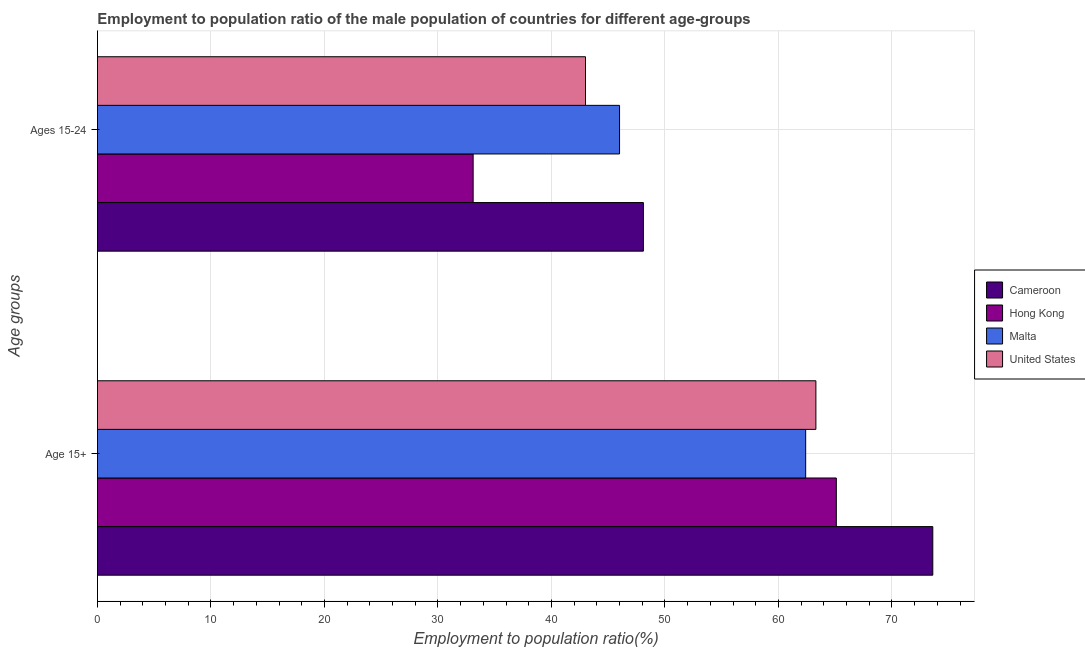How many groups of bars are there?
Make the answer very short. 2. How many bars are there on the 2nd tick from the top?
Your answer should be compact. 4. How many bars are there on the 1st tick from the bottom?
Provide a succinct answer. 4. What is the label of the 2nd group of bars from the top?
Your answer should be very brief. Age 15+. Across all countries, what is the maximum employment to population ratio(age 15-24)?
Your answer should be compact. 48.1. Across all countries, what is the minimum employment to population ratio(age 15-24)?
Offer a very short reply. 33.1. In which country was the employment to population ratio(age 15-24) maximum?
Provide a short and direct response. Cameroon. In which country was the employment to population ratio(age 15-24) minimum?
Provide a short and direct response. Hong Kong. What is the total employment to population ratio(age 15-24) in the graph?
Provide a short and direct response. 170.2. What is the difference between the employment to population ratio(age 15-24) in Hong Kong and that in United States?
Provide a succinct answer. -9.9. What is the difference between the employment to population ratio(age 15+) in Cameroon and the employment to population ratio(age 15-24) in Hong Kong?
Ensure brevity in your answer.  40.5. What is the average employment to population ratio(age 15-24) per country?
Offer a terse response. 42.55. What is the difference between the employment to population ratio(age 15-24) and employment to population ratio(age 15+) in United States?
Ensure brevity in your answer.  -20.3. In how many countries, is the employment to population ratio(age 15-24) greater than 48 %?
Keep it short and to the point. 1. What is the ratio of the employment to population ratio(age 15+) in United States to that in Malta?
Your answer should be compact. 1.01. Is the employment to population ratio(age 15+) in Cameroon less than that in Hong Kong?
Give a very brief answer. No. In how many countries, is the employment to population ratio(age 15+) greater than the average employment to population ratio(age 15+) taken over all countries?
Ensure brevity in your answer.  1. What does the 4th bar from the top in Ages 15-24 represents?
Provide a succinct answer. Cameroon. What does the 3rd bar from the bottom in Age 15+ represents?
Offer a very short reply. Malta. Are all the bars in the graph horizontal?
Your answer should be compact. Yes. How many countries are there in the graph?
Your answer should be compact. 4. Does the graph contain any zero values?
Your response must be concise. No. Where does the legend appear in the graph?
Provide a short and direct response. Center right. How are the legend labels stacked?
Offer a very short reply. Vertical. What is the title of the graph?
Your response must be concise. Employment to population ratio of the male population of countries for different age-groups. What is the label or title of the X-axis?
Provide a short and direct response. Employment to population ratio(%). What is the label or title of the Y-axis?
Provide a short and direct response. Age groups. What is the Employment to population ratio(%) in Cameroon in Age 15+?
Offer a terse response. 73.6. What is the Employment to population ratio(%) in Hong Kong in Age 15+?
Make the answer very short. 65.1. What is the Employment to population ratio(%) in Malta in Age 15+?
Provide a short and direct response. 62.4. What is the Employment to population ratio(%) in United States in Age 15+?
Give a very brief answer. 63.3. What is the Employment to population ratio(%) in Cameroon in Ages 15-24?
Keep it short and to the point. 48.1. What is the Employment to population ratio(%) of Hong Kong in Ages 15-24?
Ensure brevity in your answer.  33.1. What is the Employment to population ratio(%) of United States in Ages 15-24?
Offer a terse response. 43. Across all Age groups, what is the maximum Employment to population ratio(%) of Cameroon?
Offer a very short reply. 73.6. Across all Age groups, what is the maximum Employment to population ratio(%) in Hong Kong?
Give a very brief answer. 65.1. Across all Age groups, what is the maximum Employment to population ratio(%) in Malta?
Your answer should be compact. 62.4. Across all Age groups, what is the maximum Employment to population ratio(%) of United States?
Your answer should be very brief. 63.3. Across all Age groups, what is the minimum Employment to population ratio(%) of Cameroon?
Keep it short and to the point. 48.1. Across all Age groups, what is the minimum Employment to population ratio(%) in Hong Kong?
Your response must be concise. 33.1. Across all Age groups, what is the minimum Employment to population ratio(%) in United States?
Ensure brevity in your answer.  43. What is the total Employment to population ratio(%) of Cameroon in the graph?
Give a very brief answer. 121.7. What is the total Employment to population ratio(%) of Hong Kong in the graph?
Your response must be concise. 98.2. What is the total Employment to population ratio(%) in Malta in the graph?
Provide a succinct answer. 108.4. What is the total Employment to population ratio(%) in United States in the graph?
Keep it short and to the point. 106.3. What is the difference between the Employment to population ratio(%) in Cameroon in Age 15+ and that in Ages 15-24?
Keep it short and to the point. 25.5. What is the difference between the Employment to population ratio(%) of Hong Kong in Age 15+ and that in Ages 15-24?
Ensure brevity in your answer.  32. What is the difference between the Employment to population ratio(%) of Malta in Age 15+ and that in Ages 15-24?
Your answer should be very brief. 16.4. What is the difference between the Employment to population ratio(%) in United States in Age 15+ and that in Ages 15-24?
Your response must be concise. 20.3. What is the difference between the Employment to population ratio(%) in Cameroon in Age 15+ and the Employment to population ratio(%) in Hong Kong in Ages 15-24?
Your answer should be compact. 40.5. What is the difference between the Employment to population ratio(%) of Cameroon in Age 15+ and the Employment to population ratio(%) of Malta in Ages 15-24?
Provide a succinct answer. 27.6. What is the difference between the Employment to population ratio(%) of Cameroon in Age 15+ and the Employment to population ratio(%) of United States in Ages 15-24?
Offer a very short reply. 30.6. What is the difference between the Employment to population ratio(%) in Hong Kong in Age 15+ and the Employment to population ratio(%) in United States in Ages 15-24?
Make the answer very short. 22.1. What is the difference between the Employment to population ratio(%) of Malta in Age 15+ and the Employment to population ratio(%) of United States in Ages 15-24?
Provide a succinct answer. 19.4. What is the average Employment to population ratio(%) in Cameroon per Age groups?
Give a very brief answer. 60.85. What is the average Employment to population ratio(%) in Hong Kong per Age groups?
Your answer should be very brief. 49.1. What is the average Employment to population ratio(%) in Malta per Age groups?
Offer a terse response. 54.2. What is the average Employment to population ratio(%) of United States per Age groups?
Offer a terse response. 53.15. What is the difference between the Employment to population ratio(%) in Cameroon and Employment to population ratio(%) in Hong Kong in Age 15+?
Your answer should be very brief. 8.5. What is the difference between the Employment to population ratio(%) of Cameroon and Employment to population ratio(%) of United States in Age 15+?
Offer a very short reply. 10.3. What is the difference between the Employment to population ratio(%) in Hong Kong and Employment to population ratio(%) in Malta in Age 15+?
Your answer should be very brief. 2.7. What is the difference between the Employment to population ratio(%) of Cameroon and Employment to population ratio(%) of Hong Kong in Ages 15-24?
Your answer should be compact. 15. What is the difference between the Employment to population ratio(%) of Cameroon and Employment to population ratio(%) of United States in Ages 15-24?
Make the answer very short. 5.1. What is the ratio of the Employment to population ratio(%) of Cameroon in Age 15+ to that in Ages 15-24?
Provide a short and direct response. 1.53. What is the ratio of the Employment to population ratio(%) in Hong Kong in Age 15+ to that in Ages 15-24?
Your answer should be very brief. 1.97. What is the ratio of the Employment to population ratio(%) in Malta in Age 15+ to that in Ages 15-24?
Give a very brief answer. 1.36. What is the ratio of the Employment to population ratio(%) in United States in Age 15+ to that in Ages 15-24?
Your response must be concise. 1.47. What is the difference between the highest and the second highest Employment to population ratio(%) of Hong Kong?
Give a very brief answer. 32. What is the difference between the highest and the second highest Employment to population ratio(%) of Malta?
Offer a very short reply. 16.4. What is the difference between the highest and the second highest Employment to population ratio(%) of United States?
Give a very brief answer. 20.3. What is the difference between the highest and the lowest Employment to population ratio(%) in Cameroon?
Offer a very short reply. 25.5. What is the difference between the highest and the lowest Employment to population ratio(%) of Hong Kong?
Offer a terse response. 32. What is the difference between the highest and the lowest Employment to population ratio(%) in Malta?
Offer a very short reply. 16.4. What is the difference between the highest and the lowest Employment to population ratio(%) in United States?
Ensure brevity in your answer.  20.3. 